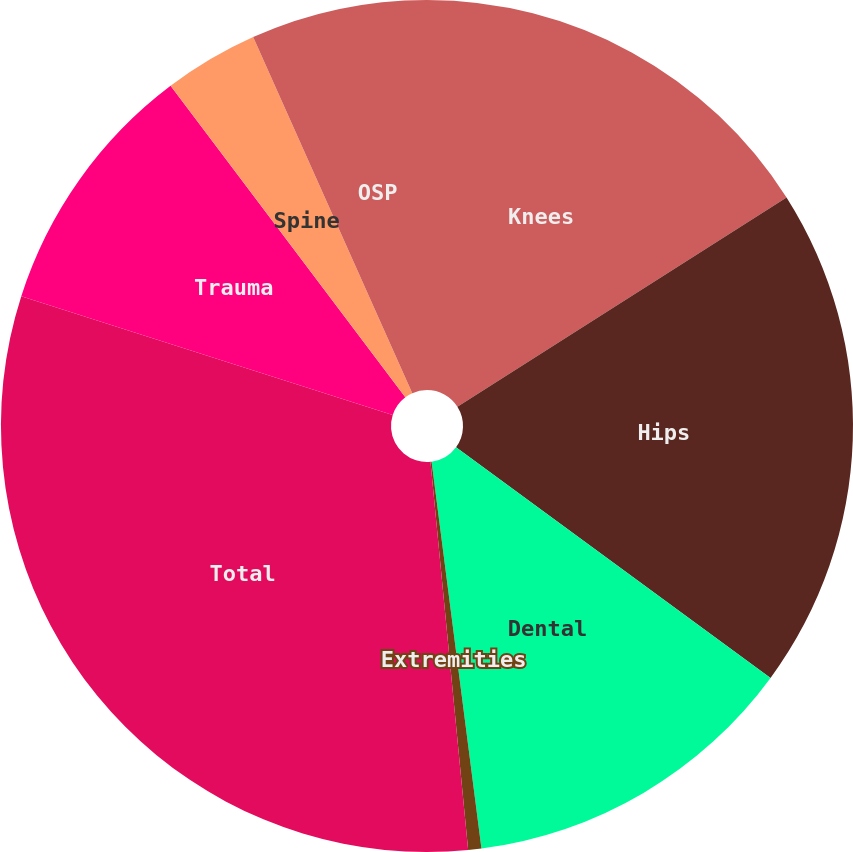<chart> <loc_0><loc_0><loc_500><loc_500><pie_chart><fcel>Knees<fcel>Hips<fcel>Dental<fcel>Extremities<fcel>Total<fcel>Trauma<fcel>Spine<fcel>OSP<nl><fcel>15.99%<fcel>19.08%<fcel>12.89%<fcel>0.5%<fcel>31.47%<fcel>9.79%<fcel>3.59%<fcel>6.69%<nl></chart> 